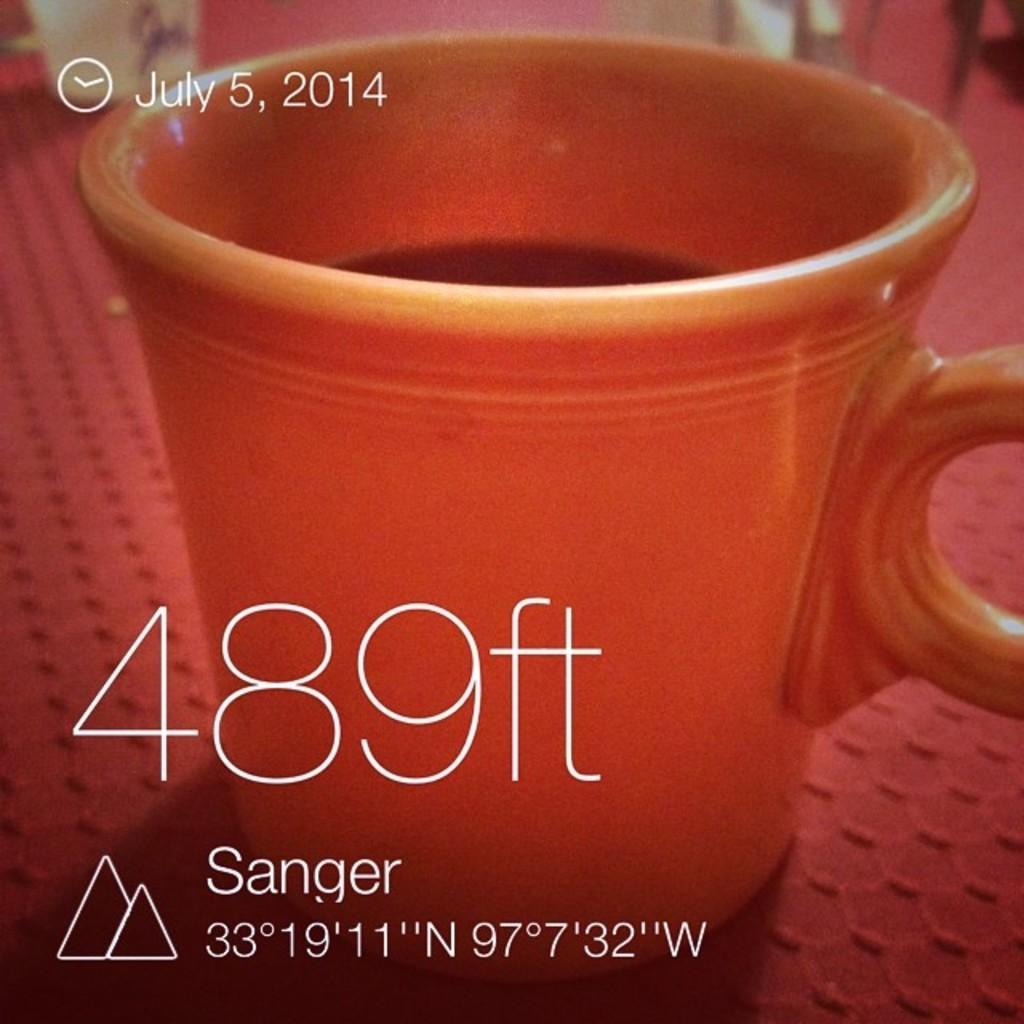Provide a one-sentence caption for the provided image. A photo of a red coffee cup with the words 489 ft displayed and the date July 5, 2014. 